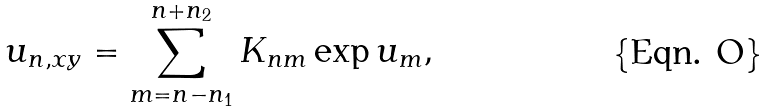Convert formula to latex. <formula><loc_0><loc_0><loc_500><loc_500>u _ { n , x y } = \sum _ { m = n - n _ { 1 } } ^ { n + n _ { 2 } } K _ { n m } \exp u _ { m } ,</formula> 